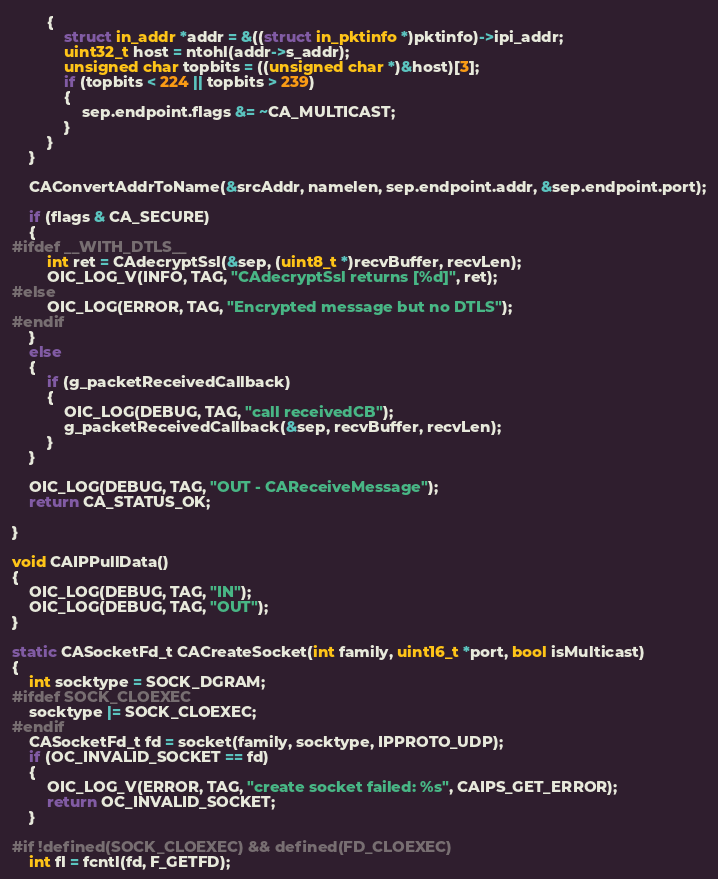<code> <loc_0><loc_0><loc_500><loc_500><_C_>        {
            struct in_addr *addr = &((struct in_pktinfo *)pktinfo)->ipi_addr;
            uint32_t host = ntohl(addr->s_addr);
            unsigned char topbits = ((unsigned char *)&host)[3];
            if (topbits < 224 || topbits > 239)
            {
                sep.endpoint.flags &= ~CA_MULTICAST;
            }
        }
    }

    CAConvertAddrToName(&srcAddr, namelen, sep.endpoint.addr, &sep.endpoint.port);

    if (flags & CA_SECURE)
    {
#ifdef __WITH_DTLS__
        int ret = CAdecryptSsl(&sep, (uint8_t *)recvBuffer, recvLen);
        OIC_LOG_V(INFO, TAG, "CAdecryptSsl returns [%d]", ret);
#else
        OIC_LOG(ERROR, TAG, "Encrypted message but no DTLS");
#endif
    }
    else
    {
        if (g_packetReceivedCallback)
        {
            OIC_LOG(DEBUG, TAG, "call receivedCB");
            g_packetReceivedCallback(&sep, recvBuffer, recvLen);
        }
    }

    OIC_LOG(DEBUG, TAG, "OUT - CAReceiveMessage");
    return CA_STATUS_OK;

}

void CAIPPullData()
{
    OIC_LOG(DEBUG, TAG, "IN");
    OIC_LOG(DEBUG, TAG, "OUT");
}

static CASocketFd_t CACreateSocket(int family, uint16_t *port, bool isMulticast)
{
    int socktype = SOCK_DGRAM;
#ifdef SOCK_CLOEXEC
    socktype |= SOCK_CLOEXEC;
#endif
    CASocketFd_t fd = socket(family, socktype, IPPROTO_UDP);
    if (OC_INVALID_SOCKET == fd)
    {
        OIC_LOG_V(ERROR, TAG, "create socket failed: %s", CAIPS_GET_ERROR);
        return OC_INVALID_SOCKET;
    }

#if !defined(SOCK_CLOEXEC) && defined(FD_CLOEXEC)
    int fl = fcntl(fd, F_GETFD);</code> 